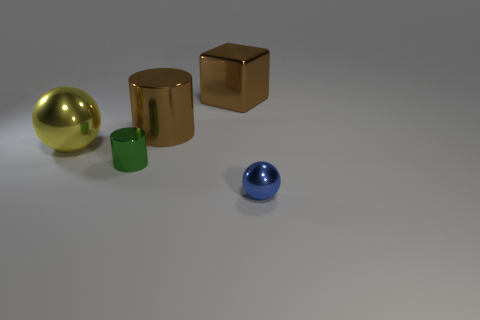There is a big metal object to the left of the tiny metal cylinder; is its shape the same as the green shiny object?
Make the answer very short. No. There is a tiny thing in front of the small metallic thing that is behind the small thing in front of the tiny shiny cylinder; what is its shape?
Keep it short and to the point. Sphere. What is the material of the large object that is behind the brown shiny cylinder?
Provide a short and direct response. Metal. What is the color of the block that is the same size as the yellow metal thing?
Ensure brevity in your answer.  Brown. What number of other things are there of the same shape as the green object?
Ensure brevity in your answer.  1. Is the yellow sphere the same size as the blue thing?
Your answer should be compact. No. Is the number of tiny metallic things to the right of the big brown metal cylinder greater than the number of big yellow things that are behind the cube?
Your answer should be compact. Yes. What number of other things are there of the same size as the green cylinder?
Provide a short and direct response. 1. Do the shiny cylinder that is behind the yellow metallic object and the metal cube have the same color?
Your answer should be very brief. Yes. Are there more brown metallic objects that are on the left side of the big ball than metal cylinders?
Provide a short and direct response. No. 